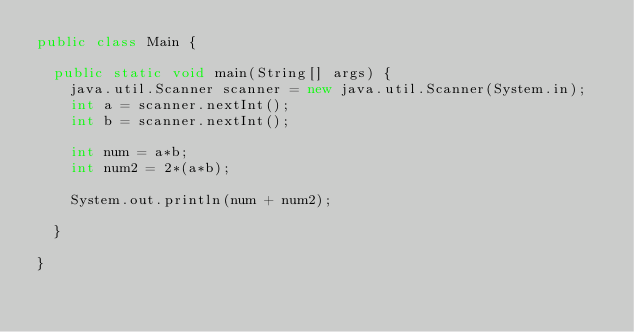Convert code to text. <code><loc_0><loc_0><loc_500><loc_500><_Java_>public class Main {

	public static void main(String[] args) {
		java.util.Scanner scanner = new java.util.Scanner(System.in);
		int a = scanner.nextInt();
		int b = scanner.nextInt();
		
		int num = a*b;
		int num2 = 2*(a*b);
		
		System.out.println(num + num2);
		
	}

}</code> 